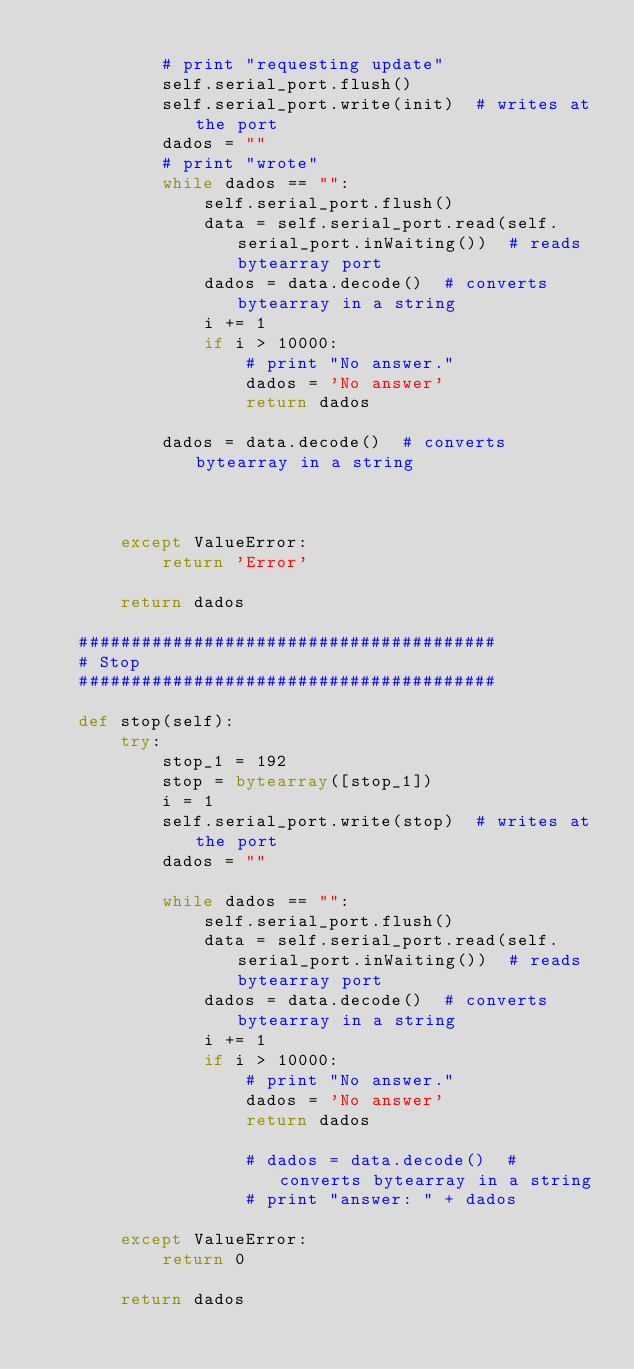Convert code to text. <code><loc_0><loc_0><loc_500><loc_500><_Python_>
            # print "requesting update"
            self.serial_port.flush()
            self.serial_port.write(init)  # writes at the port
            dados = ""
            # print "wrote"
            while dados == "":
                self.serial_port.flush()
                data = self.serial_port.read(self.serial_port.inWaiting())  # reads bytearray port
                dados = data.decode()  # converts bytearray in a string
                i += 1
                if i > 10000:
                    # print "No answer."
                    dados = 'No answer'
                    return dados

            dados = data.decode()  # converts bytearray in a string



        except ValueError:
            return 'Error'

        return dados

    ########################################
    # Stop
    ########################################

    def stop(self):
        try:
            stop_1 = 192
            stop = bytearray([stop_1])
            i = 1
            self.serial_port.write(stop)  # writes at the port
            dados = ""

            while dados == "":
                self.serial_port.flush()
                data = self.serial_port.read(self.serial_port.inWaiting())  # reads bytearray port
                dados = data.decode()  # converts bytearray in a string
                i += 1
                if i > 10000:
                    # print "No answer."
                    dados = 'No answer'
                    return dados

                    # dados = data.decode()  # converts bytearray in a string
                    # print "answer: " + dados

        except ValueError:
            return 0

        return dados
</code> 